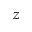<formula> <loc_0><loc_0><loc_500><loc_500>z</formula> 